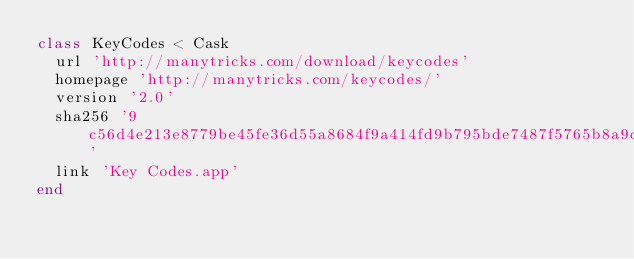Convert code to text. <code><loc_0><loc_0><loc_500><loc_500><_Ruby_>class KeyCodes < Cask
  url 'http://manytricks.com/download/keycodes'
  homepage 'http://manytricks.com/keycodes/'
  version '2.0'
  sha256 '9c56d4e213e8779be45fe36d55a8684f9a414fd9b795bde7487f5765b8a9d694'
  link 'Key Codes.app'
end
</code> 